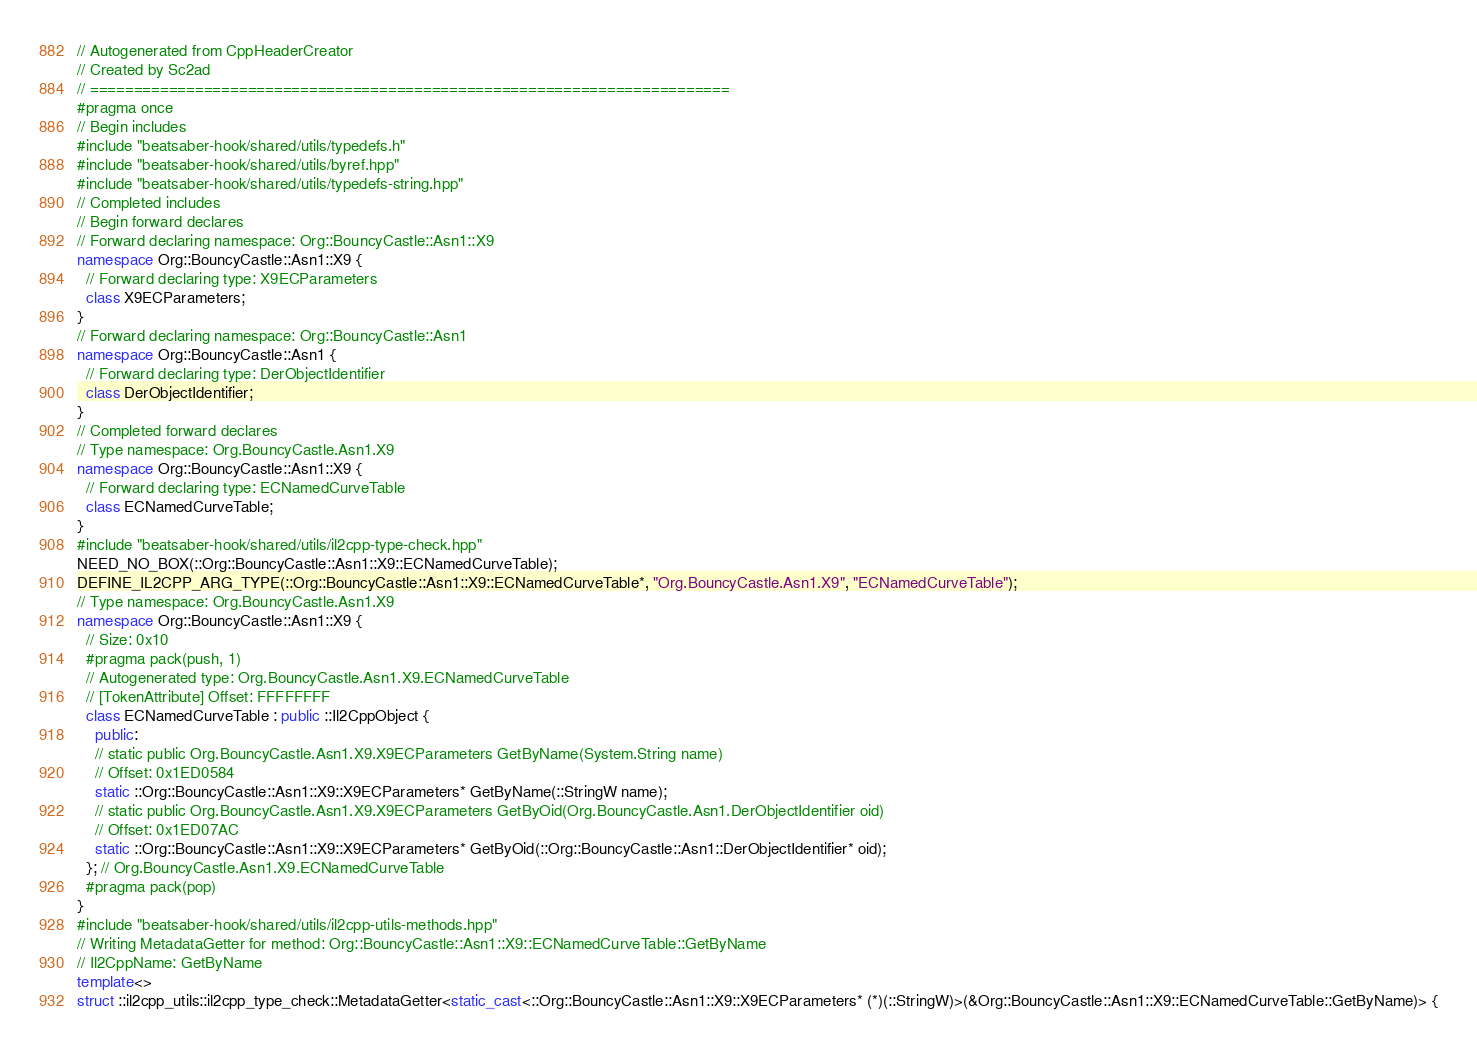<code> <loc_0><loc_0><loc_500><loc_500><_C++_>// Autogenerated from CppHeaderCreator
// Created by Sc2ad
// =========================================================================
#pragma once
// Begin includes
#include "beatsaber-hook/shared/utils/typedefs.h"
#include "beatsaber-hook/shared/utils/byref.hpp"
#include "beatsaber-hook/shared/utils/typedefs-string.hpp"
// Completed includes
// Begin forward declares
// Forward declaring namespace: Org::BouncyCastle::Asn1::X9
namespace Org::BouncyCastle::Asn1::X9 {
  // Forward declaring type: X9ECParameters
  class X9ECParameters;
}
// Forward declaring namespace: Org::BouncyCastle::Asn1
namespace Org::BouncyCastle::Asn1 {
  // Forward declaring type: DerObjectIdentifier
  class DerObjectIdentifier;
}
// Completed forward declares
// Type namespace: Org.BouncyCastle.Asn1.X9
namespace Org::BouncyCastle::Asn1::X9 {
  // Forward declaring type: ECNamedCurveTable
  class ECNamedCurveTable;
}
#include "beatsaber-hook/shared/utils/il2cpp-type-check.hpp"
NEED_NO_BOX(::Org::BouncyCastle::Asn1::X9::ECNamedCurveTable);
DEFINE_IL2CPP_ARG_TYPE(::Org::BouncyCastle::Asn1::X9::ECNamedCurveTable*, "Org.BouncyCastle.Asn1.X9", "ECNamedCurveTable");
// Type namespace: Org.BouncyCastle.Asn1.X9
namespace Org::BouncyCastle::Asn1::X9 {
  // Size: 0x10
  #pragma pack(push, 1)
  // Autogenerated type: Org.BouncyCastle.Asn1.X9.ECNamedCurveTable
  // [TokenAttribute] Offset: FFFFFFFF
  class ECNamedCurveTable : public ::Il2CppObject {
    public:
    // static public Org.BouncyCastle.Asn1.X9.X9ECParameters GetByName(System.String name)
    // Offset: 0x1ED0584
    static ::Org::BouncyCastle::Asn1::X9::X9ECParameters* GetByName(::StringW name);
    // static public Org.BouncyCastle.Asn1.X9.X9ECParameters GetByOid(Org.BouncyCastle.Asn1.DerObjectIdentifier oid)
    // Offset: 0x1ED07AC
    static ::Org::BouncyCastle::Asn1::X9::X9ECParameters* GetByOid(::Org::BouncyCastle::Asn1::DerObjectIdentifier* oid);
  }; // Org.BouncyCastle.Asn1.X9.ECNamedCurveTable
  #pragma pack(pop)
}
#include "beatsaber-hook/shared/utils/il2cpp-utils-methods.hpp"
// Writing MetadataGetter for method: Org::BouncyCastle::Asn1::X9::ECNamedCurveTable::GetByName
// Il2CppName: GetByName
template<>
struct ::il2cpp_utils::il2cpp_type_check::MetadataGetter<static_cast<::Org::BouncyCastle::Asn1::X9::X9ECParameters* (*)(::StringW)>(&Org::BouncyCastle::Asn1::X9::ECNamedCurveTable::GetByName)> {</code> 